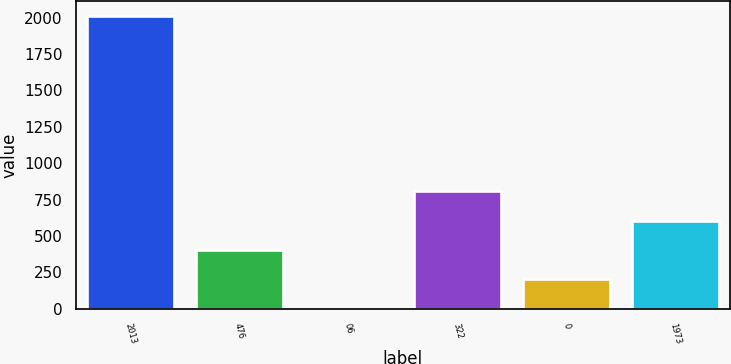Convert chart. <chart><loc_0><loc_0><loc_500><loc_500><bar_chart><fcel>2013<fcel>476<fcel>06<fcel>322<fcel>0<fcel>1973<nl><fcel>2012<fcel>403.04<fcel>0.8<fcel>805.28<fcel>201.92<fcel>604.16<nl></chart> 